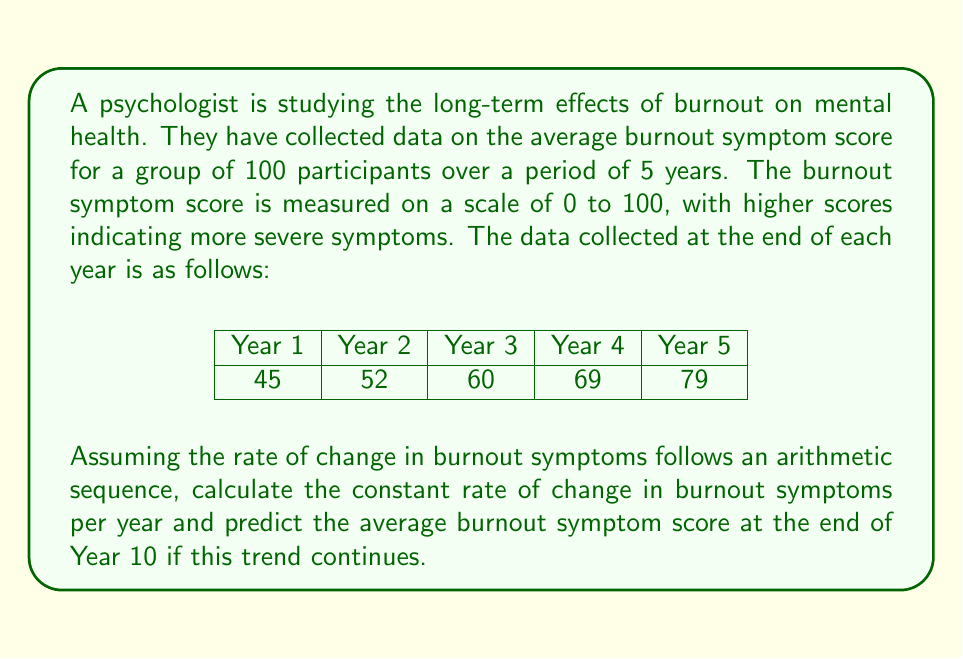Could you help me with this problem? To solve this problem, we'll follow these steps:

1. Determine if the sequence is arithmetic:
   Let's calculate the differences between consecutive terms:
   $52 - 45 = 7$
   $60 - 52 = 8$
   $69 - 60 = 9$
   $79 - 69 = 10$

   The differences are not constant, so this is not a perfect arithmetic sequence. However, the question asks us to assume it is, so we'll calculate the average difference.

2. Calculate the average rate of change:
   $$\text{Average rate of change} = \frac{\text{Total change}}{\text{Number of intervals}}$$
   $$= \frac{79 - 45}{5 - 1} = \frac{34}{4} = 8.5$$

3. Use the arithmetic sequence formula to predict the score at Year 10:
   For an arithmetic sequence, the nth term is given by:
   $$a_n = a_1 + (n - 1)d$$
   where $a_1$ is the first term, $n$ is the position of the term, and $d$ is the common difference.

   In this case:
   $a_1 = 45$ (Year 1 score)
   $d = 8.5$ (average rate of change)
   $n = 10$ (we want the 10th year)

   $$a_{10} = 45 + (10 - 1) \times 8.5$$
   $$= 45 + 9 \times 8.5$$
   $$= 45 + 76.5$$
   $$= 121.5$$

4. Interpret the result:
   Since the burnout symptom score is measured on a scale of 0 to 100, we need to cap our result at 100.
Answer: The constant rate of change in burnout symptoms is 8.5 points per year. The predicted average burnout symptom score at the end of Year 10 would be 100 (capped at the maximum score). 